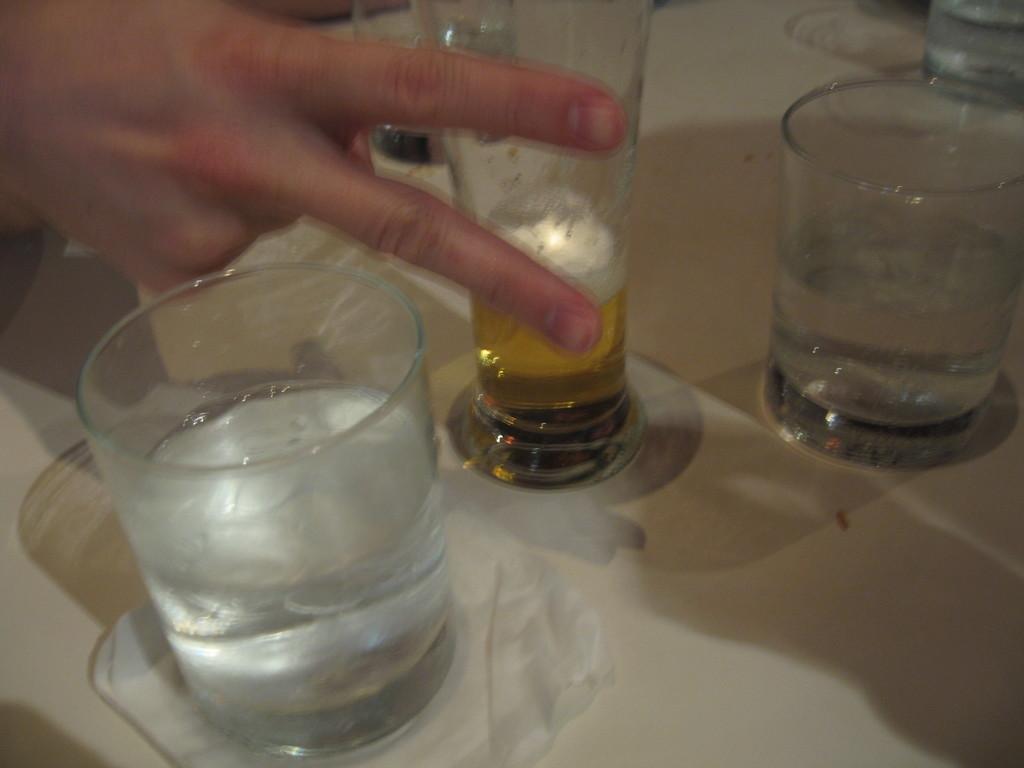How would you summarize this image in a sentence or two? In this image we can see glasses on the table. There is a person's hand. 